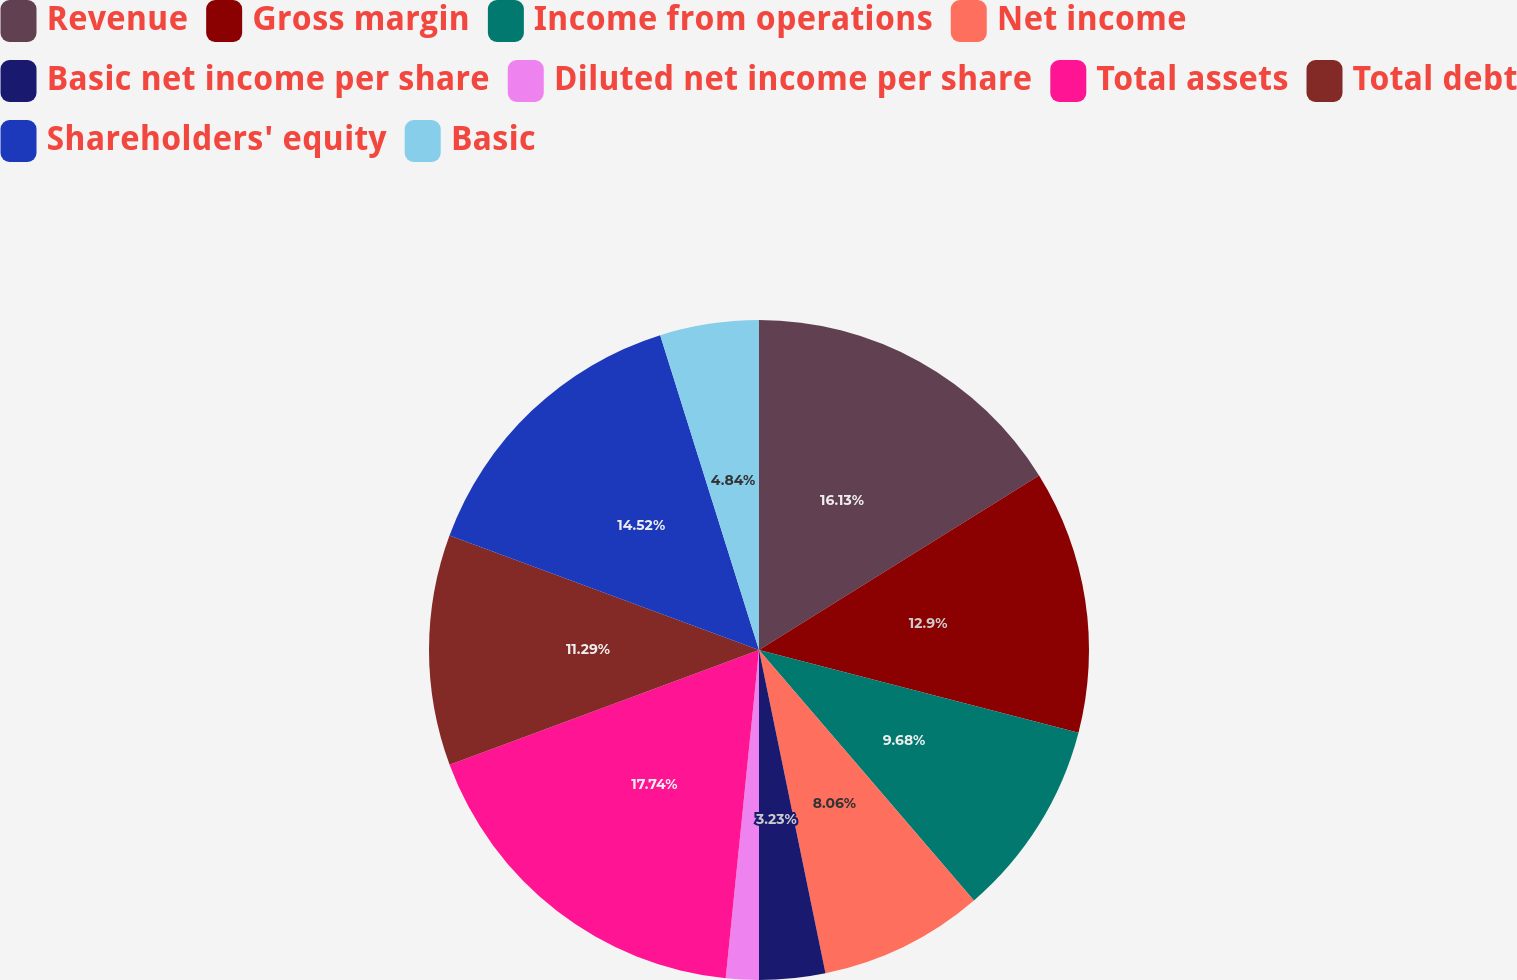Convert chart to OTSL. <chart><loc_0><loc_0><loc_500><loc_500><pie_chart><fcel>Revenue<fcel>Gross margin<fcel>Income from operations<fcel>Net income<fcel>Basic net income per share<fcel>Diluted net income per share<fcel>Total assets<fcel>Total debt<fcel>Shareholders' equity<fcel>Basic<nl><fcel>16.13%<fcel>12.9%<fcel>9.68%<fcel>8.06%<fcel>3.23%<fcel>1.61%<fcel>17.74%<fcel>11.29%<fcel>14.52%<fcel>4.84%<nl></chart> 